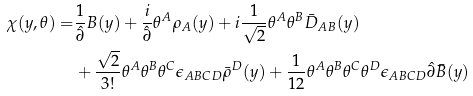<formula> <loc_0><loc_0><loc_500><loc_500>\chi ( y , \theta ) = & \frac { 1 } { \hat { \partial } } B ( y ) + \frac { i } { \hat { \partial } } \theta ^ { A } \rho _ { A } ( y ) + i \frac { 1 } { \sqrt { 2 } } \theta ^ { A } \theta ^ { B } \bar { D } _ { A B } ( y ) \\ & + \frac { \sqrt { 2 } } { 3 ! } \theta ^ { A } \theta ^ { B } \theta ^ { C } \epsilon _ { A B C D } \bar { \rho } ^ { D } ( y ) + \frac { 1 } { 1 2 } \theta ^ { A } \theta ^ { B } \theta ^ { C } \theta ^ { D } \epsilon _ { A B C D } \hat { \partial } \bar { B } ( y )</formula> 